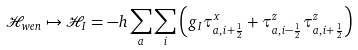Convert formula to latex. <formula><loc_0><loc_0><loc_500><loc_500>\mathcal { H } _ { w e n } \mapsto \mathcal { H } _ { I } = - h \sum _ { a } \sum _ { i } \left ( g _ { I } \tau _ { a , i + \frac { 1 } { 2 } } ^ { x } + \tau _ { a , i - \frac { 1 } { 2 } } ^ { z } \tau _ { a , i + \frac { 1 } { 2 } } ^ { z } \right )</formula> 